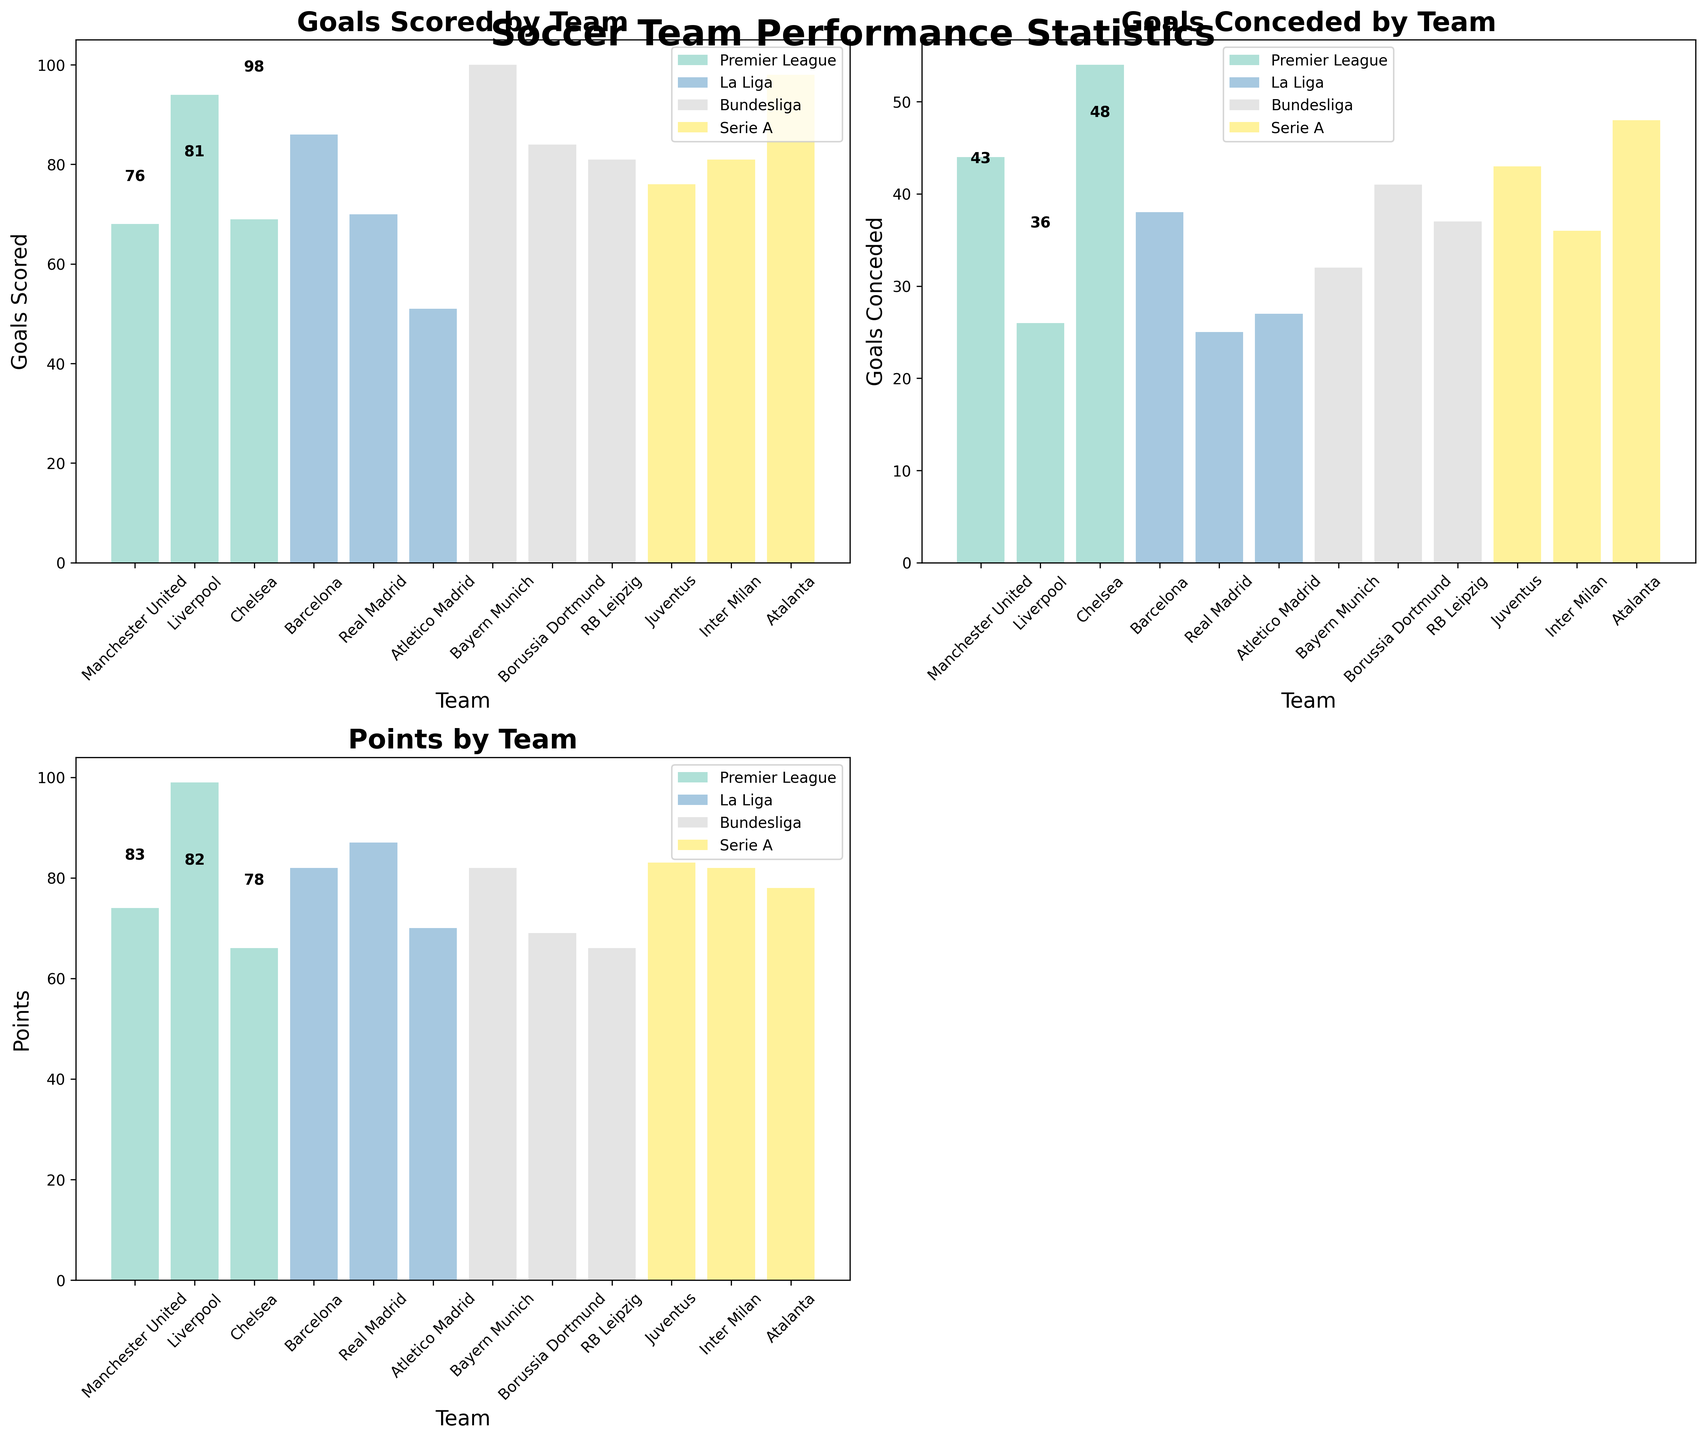what metric is displayed by the bottom-left subplot? The bottom-left subplot compares the Points metric across different soccer teams. By looking at the title "Points by Team", we can identify that it is showing the Points earned by each team.
Answer: Points How many leagues are depicted in the figure? The figure has a different color for each league, and according to the legend, there are four leagues: Premier League, La Liga, Bundesliga, and Serie A.
Answer: 4 Which team in the Bundesliga scored the highest number of goals? By looking at the top-left subplot, we can see that Bayern Munich has the highest bar within the Bundesliga teams, indicating they scored the most goals (100).
Answer: Bayern Munich What is the total number of goals scored by all Premier League teams combined? In the top-left subplot, the bars for Manchester United, Liverpool, and Chelsea show their goal counts as 68, 94, and 69 respectively. Adding these together gives 68 + 94 + 69 = 231.
Answer: 231 What is the difference in points between Real Madrid and Barcelona? In the bottom-left subplot, Real Madrid has a bar representing 87 points while Barcelona has a bar representing 82 points. The difference is 87 - 82 = 5 points.
Answer: 5 Which team conceded the least number of goals among La Liga teams? In the top-right subplot, the bar representing goals conceded by Real Madrid is the shortest among La Liga teams, indicating they conceded the least goals (25).
Answer: Real Madrid Which league's team has the highest number of points? By examining the bottom-left subplot, Liverpool from the Premier League has the tallest bar, representing the highest number of points (99).
Answer: Premier League What's the average number of goals scored by Serie A teams? In the top-left subplot, the goals for Serie A teams (Juventus, Inter Milan, Atalanta) are 76, 81, and 98 respectively. ((76 + 81 + 98) / 3) = 85 goals on average.
Answer: 85 Between Bayern Munich and Borussia Dortmund, which team conceded more goals? The top-right subplot shows the bars for Bayern Munich and Borussia Dortmund. Bayern Munich's bar represents 32 goals conceded, while Borussia Dortmund's bar represents 41 goals conceded. Therefore, Borussia Dortmund conceded more goals.
Answer: Borussia Dortmund 